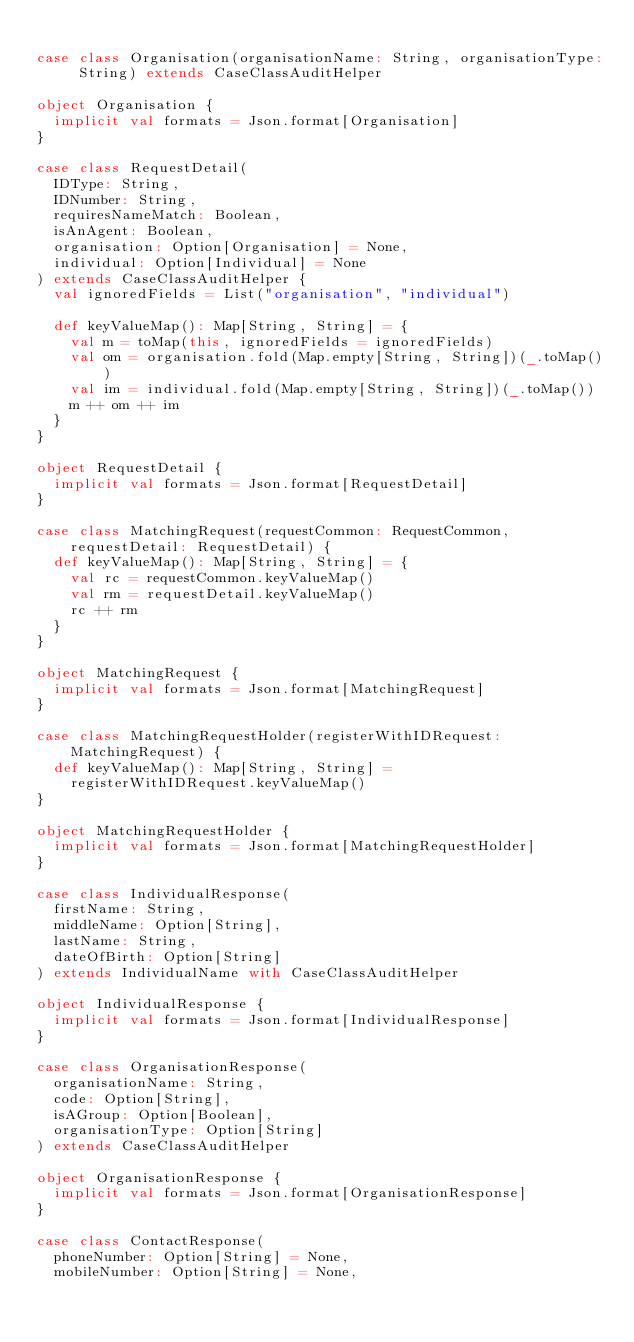Convert code to text. <code><loc_0><loc_0><loc_500><loc_500><_Scala_>
case class Organisation(organisationName: String, organisationType: String) extends CaseClassAuditHelper

object Organisation {
  implicit val formats = Json.format[Organisation]
}

case class RequestDetail(
  IDType: String,
  IDNumber: String,
  requiresNameMatch: Boolean,
  isAnAgent: Boolean,
  organisation: Option[Organisation] = None,
  individual: Option[Individual] = None
) extends CaseClassAuditHelper {
  val ignoredFields = List("organisation", "individual")

  def keyValueMap(): Map[String, String] = {
    val m = toMap(this, ignoredFields = ignoredFields)
    val om = organisation.fold(Map.empty[String, String])(_.toMap())
    val im = individual.fold(Map.empty[String, String])(_.toMap())
    m ++ om ++ im
  }
}

object RequestDetail {
  implicit val formats = Json.format[RequestDetail]
}

case class MatchingRequest(requestCommon: RequestCommon, requestDetail: RequestDetail) {
  def keyValueMap(): Map[String, String] = {
    val rc = requestCommon.keyValueMap()
    val rm = requestDetail.keyValueMap()
    rc ++ rm
  }
}

object MatchingRequest {
  implicit val formats = Json.format[MatchingRequest]
}

case class MatchingRequestHolder(registerWithIDRequest: MatchingRequest) {
  def keyValueMap(): Map[String, String] =
    registerWithIDRequest.keyValueMap()
}

object MatchingRequestHolder {
  implicit val formats = Json.format[MatchingRequestHolder]
}

case class IndividualResponse(
  firstName: String,
  middleName: Option[String],
  lastName: String,
  dateOfBirth: Option[String]
) extends IndividualName with CaseClassAuditHelper

object IndividualResponse {
  implicit val formats = Json.format[IndividualResponse]
}

case class OrganisationResponse(
  organisationName: String,
  code: Option[String],
  isAGroup: Option[Boolean],
  organisationType: Option[String]
) extends CaseClassAuditHelper

object OrganisationResponse {
  implicit val formats = Json.format[OrganisationResponse]
}

case class ContactResponse(
  phoneNumber: Option[String] = None,
  mobileNumber: Option[String] = None,</code> 